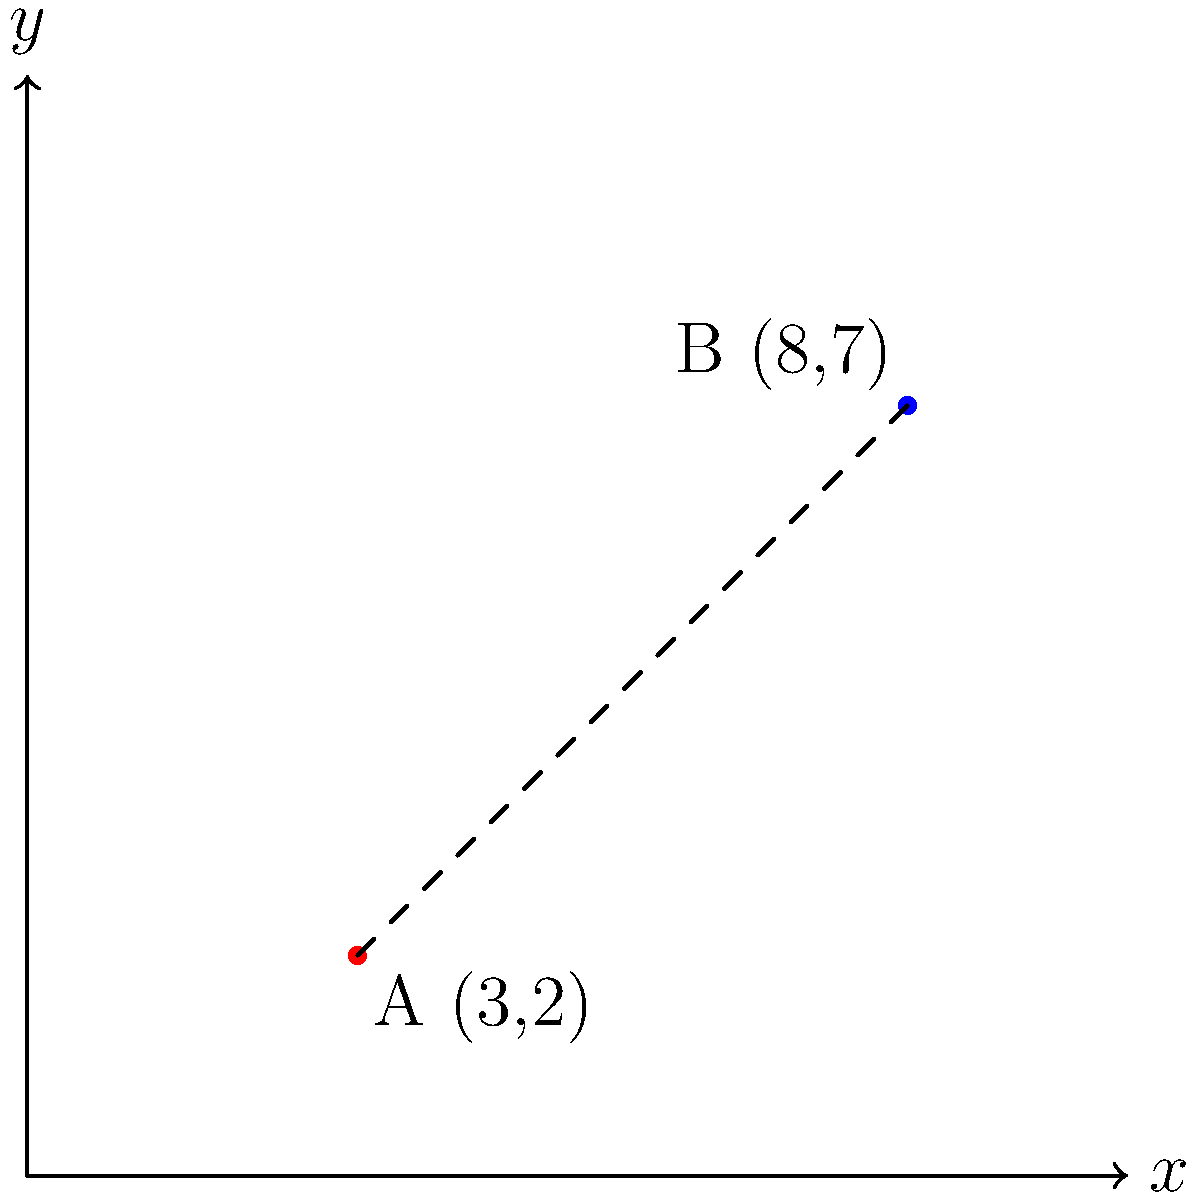Two crime scenes have been reported at locations A(3,2) and B(8,7) on the city grid. As the investigating officer, you need to determine the straight-line distance between these two locations. Using the coordinate system provided, calculate the distance between points A and B to the nearest tenth of a unit. To find the distance between two points in a coordinate system, we can use the distance formula:

$$d = \sqrt{(x_2-x_1)^2 + (y_2-y_1)^2}$$

Where $(x_1,y_1)$ are the coordinates of the first point and $(x_2,y_2)$ are the coordinates of the second point.

Step 1: Identify the coordinates
Point A: $(x_1,y_1) = (3,2)$
Point B: $(x_2,y_2) = (8,7)$

Step 2: Plug the values into the distance formula
$$d = \sqrt{(8-3)^2 + (7-2)^2}$$

Step 3: Simplify the expressions inside the parentheses
$$d = \sqrt{5^2 + 5^2}$$

Step 4: Calculate the squares
$$d = \sqrt{25 + 25}$$

Step 5: Add the values under the square root
$$d = \sqrt{50}$$

Step 6: Simplify the square root
$$d = 5\sqrt{2} \approx 7.071$$

Step 7: Round to the nearest tenth
$$d \approx 7.1$$

Therefore, the distance between the two crime scenes is approximately 7.1 units.
Answer: 7.1 units 